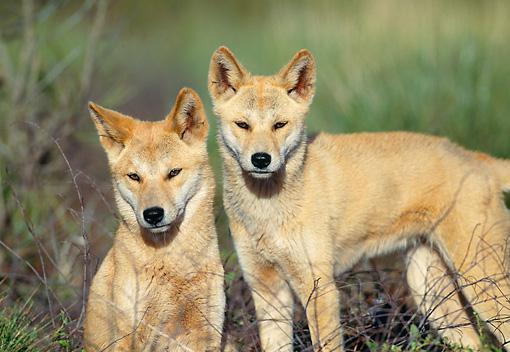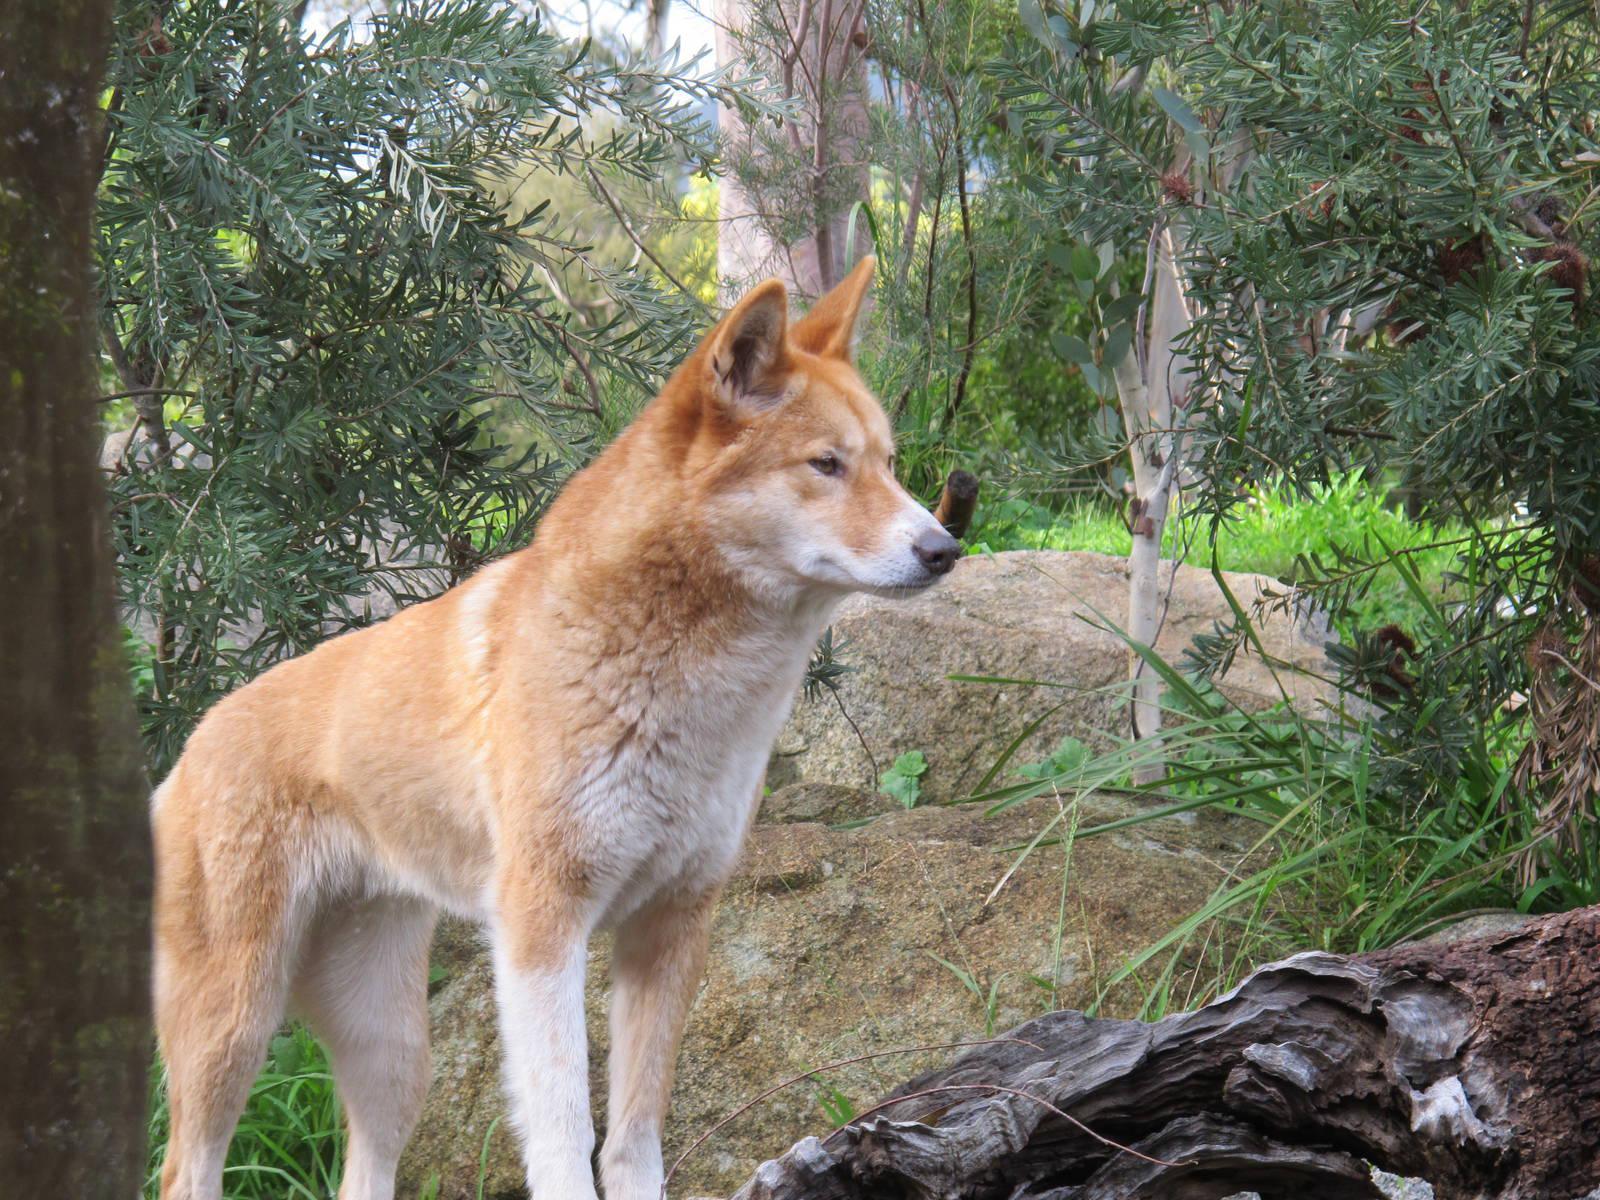The first image is the image on the left, the second image is the image on the right. Evaluate the accuracy of this statement regarding the images: "The left image contains exactly two wild dogs.". Is it true? Answer yes or no. Yes. 